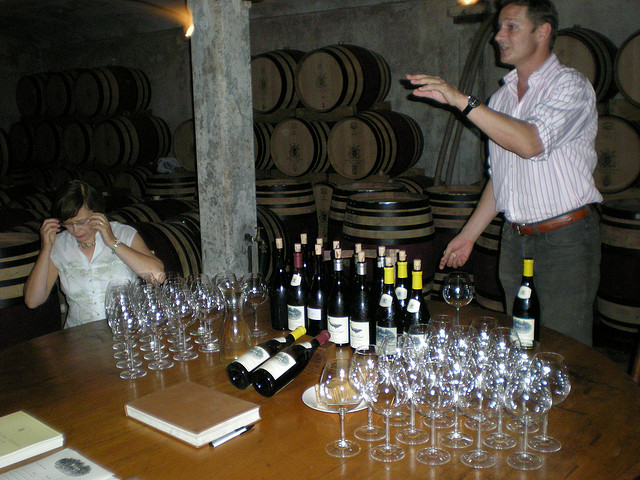What can you infer about the type of wine featured in the tasting from the bottles and setting? Based on the setting and the prominence of oak barrels, it suggests that the wines featured could be aged reds, which are commonly stored in oak to enhance their flavor complexity. The bottles' labeling isn't clearly visible, but their shape and coloration hint that they might be from a particular region or producer known for their oak-aged wines. This type of setting is often associated with more traditional, established wineries. 